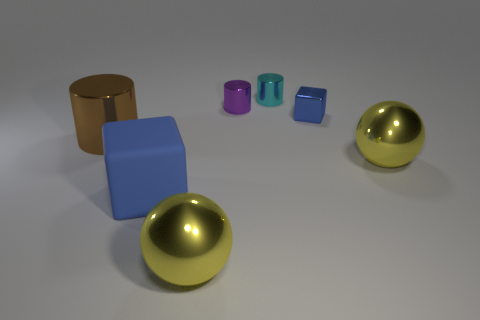Subtract all tiny shiny cylinders. How many cylinders are left? 1 Add 1 blue metallic objects. How many objects exist? 8 Subtract 1 cylinders. How many cylinders are left? 2 Subtract all blocks. How many objects are left? 5 Subtract all large metallic things. Subtract all blue matte cubes. How many objects are left? 3 Add 4 big yellow shiny balls. How many big yellow shiny balls are left? 6 Add 1 red shiny cylinders. How many red shiny cylinders exist? 1 Subtract 0 gray balls. How many objects are left? 7 Subtract all red cylinders. Subtract all red blocks. How many cylinders are left? 3 